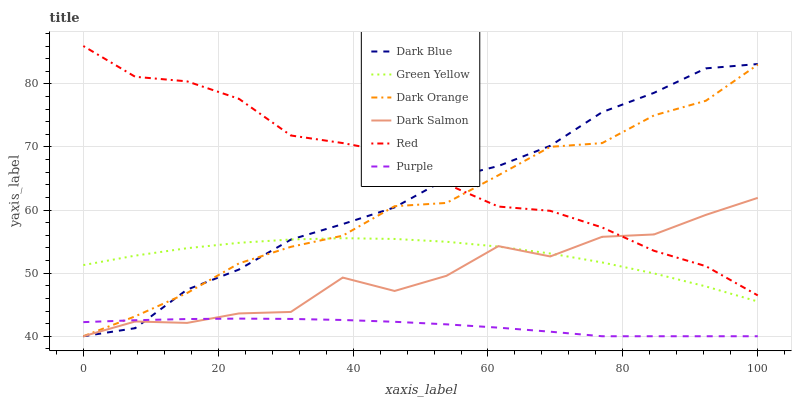Does Purple have the minimum area under the curve?
Answer yes or no. Yes. Does Red have the maximum area under the curve?
Answer yes or no. Yes. Does Dark Salmon have the minimum area under the curve?
Answer yes or no. No. Does Dark Salmon have the maximum area under the curve?
Answer yes or no. No. Is Purple the smoothest?
Answer yes or no. Yes. Is Dark Salmon the roughest?
Answer yes or no. Yes. Is Dark Salmon the smoothest?
Answer yes or no. No. Is Purple the roughest?
Answer yes or no. No. Does Dark Orange have the lowest value?
Answer yes or no. Yes. Does Green Yellow have the lowest value?
Answer yes or no. No. Does Red have the highest value?
Answer yes or no. Yes. Does Dark Salmon have the highest value?
Answer yes or no. No. Is Purple less than Red?
Answer yes or no. Yes. Is Green Yellow greater than Purple?
Answer yes or no. Yes. Does Dark Orange intersect Dark Blue?
Answer yes or no. Yes. Is Dark Orange less than Dark Blue?
Answer yes or no. No. Is Dark Orange greater than Dark Blue?
Answer yes or no. No. Does Purple intersect Red?
Answer yes or no. No. 